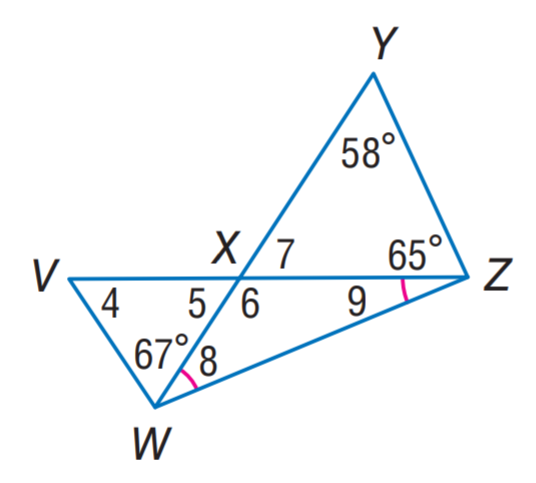Answer the mathemtical geometry problem and directly provide the correct option letter.
Question: Find m \angle 8.
Choices: A: 28 B: 28.5 C: 56 D: 57 B 